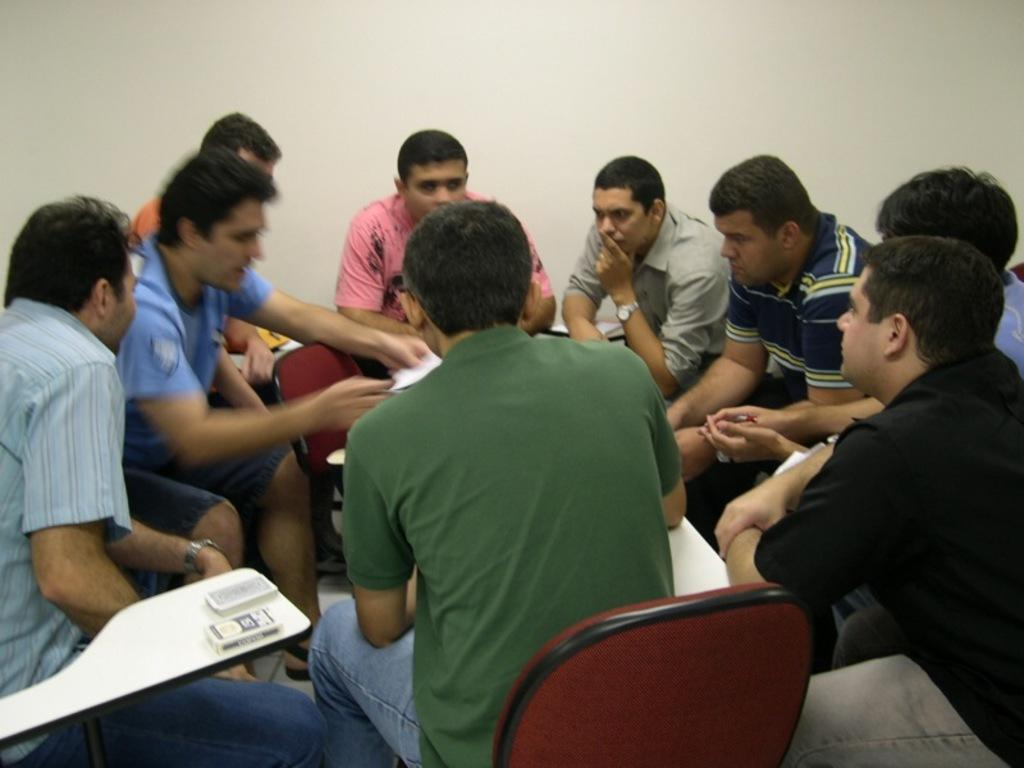Where was the image taken? The image was taken inside a room. How many men are present in the image? There are nine men in the image. What are the men doing in the image? The men are sitting on chairs and engaged in a discussion. What can be seen in the background of the image? There is a white wall visible in the background. Can you tell me how many bees are buzzing around the men in the image? There are no bees present in the image; it is taken inside a room with a group of men engaged in a discussion. What type of bone is visible on the table in the image? There is no bone visible on the table in the image; it only shows the men sitting on chairs and discussing. 